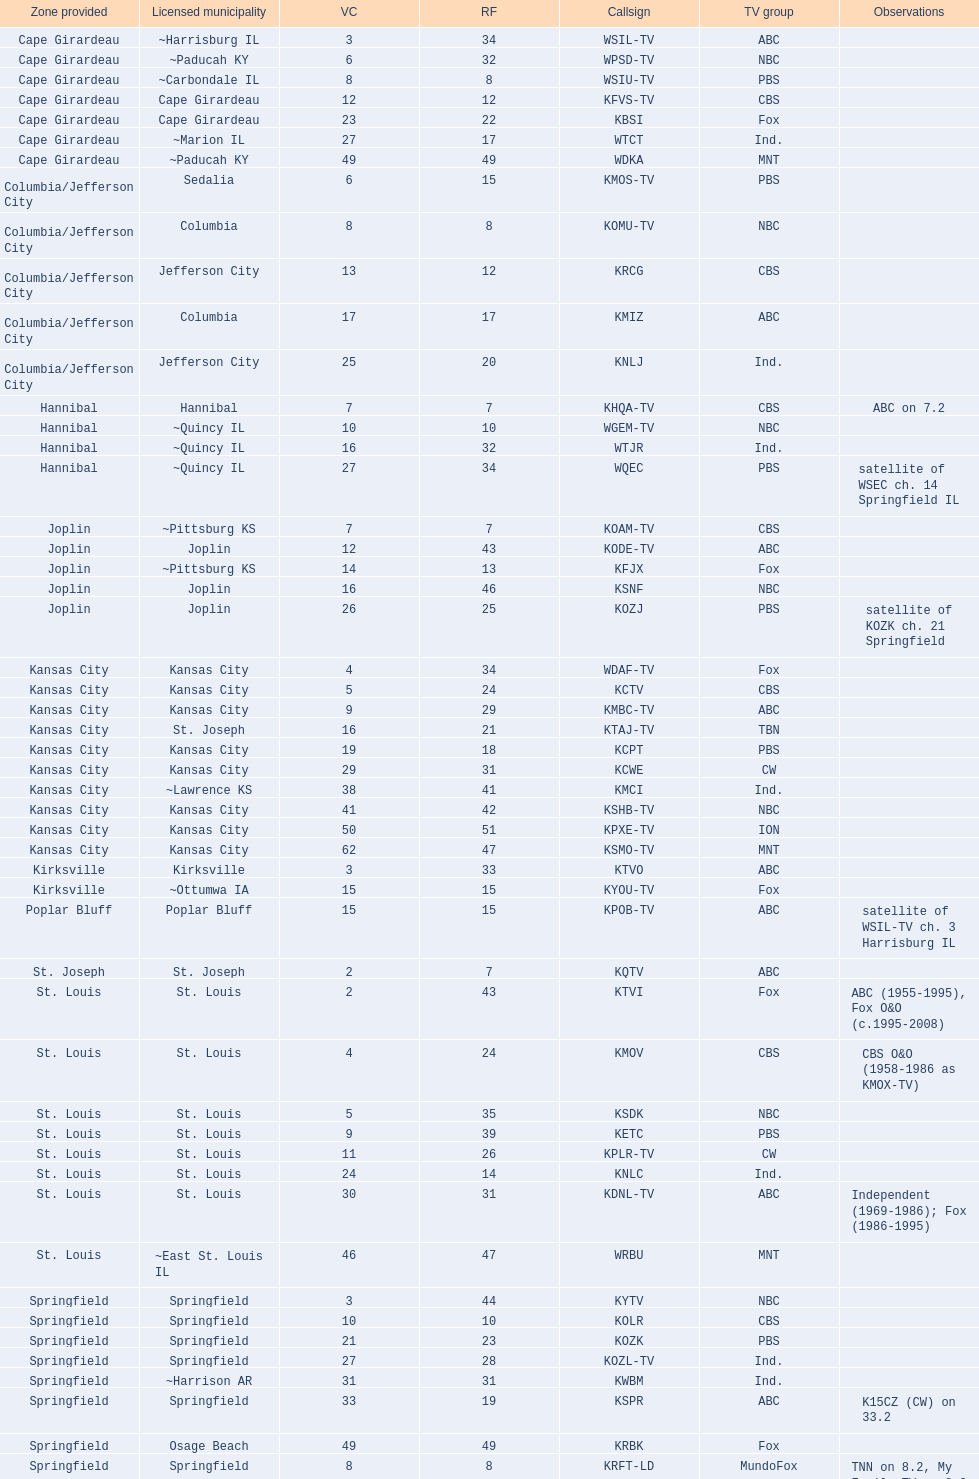What is the cumulative number of cbs stations? 7. 